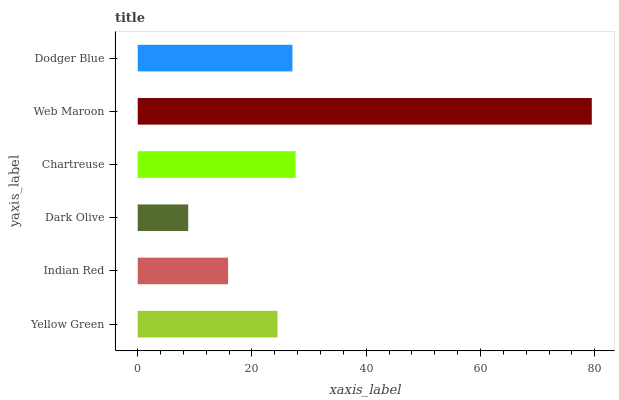Is Dark Olive the minimum?
Answer yes or no. Yes. Is Web Maroon the maximum?
Answer yes or no. Yes. Is Indian Red the minimum?
Answer yes or no. No. Is Indian Red the maximum?
Answer yes or no. No. Is Yellow Green greater than Indian Red?
Answer yes or no. Yes. Is Indian Red less than Yellow Green?
Answer yes or no. Yes. Is Indian Red greater than Yellow Green?
Answer yes or no. No. Is Yellow Green less than Indian Red?
Answer yes or no. No. Is Dodger Blue the high median?
Answer yes or no. Yes. Is Yellow Green the low median?
Answer yes or no. Yes. Is Dark Olive the high median?
Answer yes or no. No. Is Dark Olive the low median?
Answer yes or no. No. 